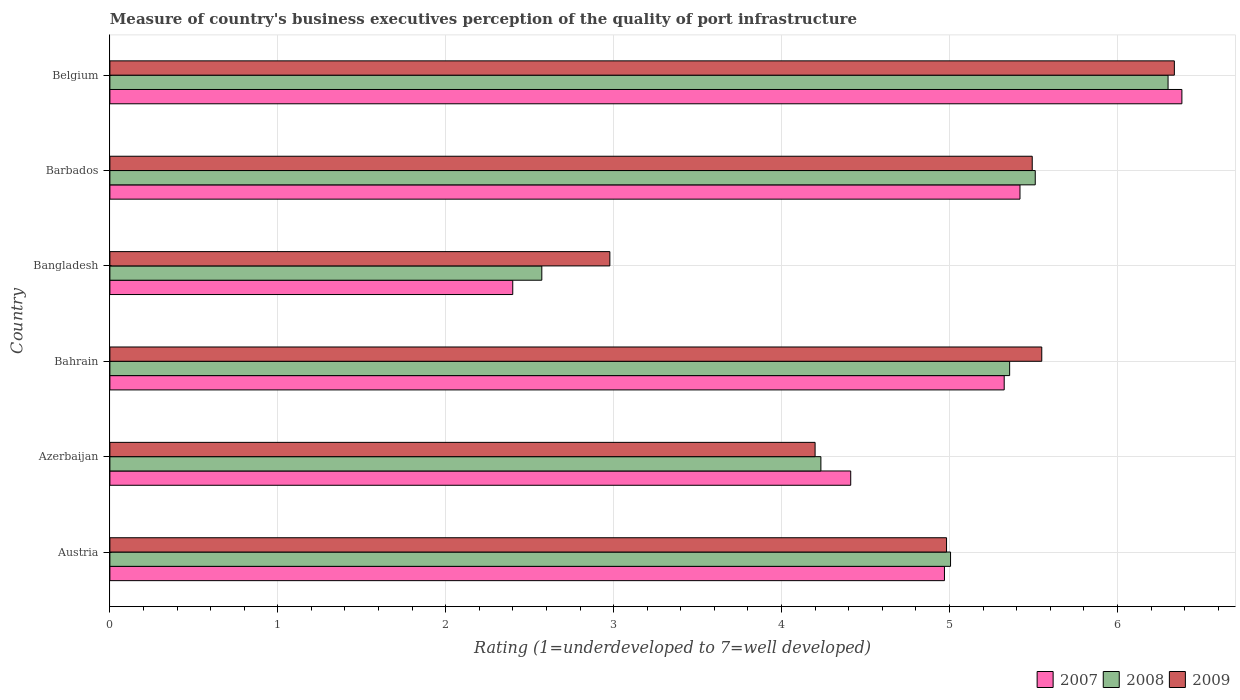How many bars are there on the 2nd tick from the bottom?
Provide a short and direct response. 3. In how many cases, is the number of bars for a given country not equal to the number of legend labels?
Your answer should be very brief. 0. What is the ratings of the quality of port infrastructure in 2007 in Bangladesh?
Your response must be concise. 2.4. Across all countries, what is the maximum ratings of the quality of port infrastructure in 2008?
Keep it short and to the point. 6.3. Across all countries, what is the minimum ratings of the quality of port infrastructure in 2009?
Provide a short and direct response. 2.98. In which country was the ratings of the quality of port infrastructure in 2007 minimum?
Give a very brief answer. Bangladesh. What is the total ratings of the quality of port infrastructure in 2007 in the graph?
Your answer should be very brief. 28.91. What is the difference between the ratings of the quality of port infrastructure in 2007 in Austria and that in Bangladesh?
Keep it short and to the point. 2.57. What is the difference between the ratings of the quality of port infrastructure in 2008 in Barbados and the ratings of the quality of port infrastructure in 2009 in Azerbaijan?
Give a very brief answer. 1.31. What is the average ratings of the quality of port infrastructure in 2008 per country?
Provide a short and direct response. 4.83. What is the difference between the ratings of the quality of port infrastructure in 2007 and ratings of the quality of port infrastructure in 2008 in Belgium?
Your answer should be very brief. 0.08. In how many countries, is the ratings of the quality of port infrastructure in 2009 greater than 4.2 ?
Offer a very short reply. 4. What is the ratio of the ratings of the quality of port infrastructure in 2007 in Bangladesh to that in Belgium?
Keep it short and to the point. 0.38. Is the ratings of the quality of port infrastructure in 2008 in Bahrain less than that in Barbados?
Give a very brief answer. Yes. Is the difference between the ratings of the quality of port infrastructure in 2007 in Bahrain and Belgium greater than the difference between the ratings of the quality of port infrastructure in 2008 in Bahrain and Belgium?
Ensure brevity in your answer.  No. What is the difference between the highest and the second highest ratings of the quality of port infrastructure in 2007?
Ensure brevity in your answer.  0.96. What is the difference between the highest and the lowest ratings of the quality of port infrastructure in 2009?
Keep it short and to the point. 3.36. Is the sum of the ratings of the quality of port infrastructure in 2009 in Bangladesh and Belgium greater than the maximum ratings of the quality of port infrastructure in 2007 across all countries?
Provide a succinct answer. Yes. What does the 1st bar from the top in Barbados represents?
Offer a terse response. 2009. How many bars are there?
Offer a very short reply. 18. How many countries are there in the graph?
Your answer should be compact. 6. What is the difference between two consecutive major ticks on the X-axis?
Your answer should be compact. 1. Are the values on the major ticks of X-axis written in scientific E-notation?
Provide a succinct answer. No. Where does the legend appear in the graph?
Your answer should be very brief. Bottom right. How many legend labels are there?
Offer a very short reply. 3. How are the legend labels stacked?
Provide a succinct answer. Horizontal. What is the title of the graph?
Make the answer very short. Measure of country's business executives perception of the quality of port infrastructure. Does "1961" appear as one of the legend labels in the graph?
Keep it short and to the point. No. What is the label or title of the X-axis?
Keep it short and to the point. Rating (1=underdeveloped to 7=well developed). What is the Rating (1=underdeveloped to 7=well developed) of 2007 in Austria?
Provide a succinct answer. 4.97. What is the Rating (1=underdeveloped to 7=well developed) in 2008 in Austria?
Provide a succinct answer. 5.01. What is the Rating (1=underdeveloped to 7=well developed) of 2009 in Austria?
Your response must be concise. 4.98. What is the Rating (1=underdeveloped to 7=well developed) of 2007 in Azerbaijan?
Your answer should be compact. 4.41. What is the Rating (1=underdeveloped to 7=well developed) of 2008 in Azerbaijan?
Provide a succinct answer. 4.23. What is the Rating (1=underdeveloped to 7=well developed) of 2009 in Azerbaijan?
Ensure brevity in your answer.  4.2. What is the Rating (1=underdeveloped to 7=well developed) of 2007 in Bahrain?
Offer a very short reply. 5.33. What is the Rating (1=underdeveloped to 7=well developed) in 2008 in Bahrain?
Your answer should be very brief. 5.36. What is the Rating (1=underdeveloped to 7=well developed) in 2009 in Bahrain?
Make the answer very short. 5.55. What is the Rating (1=underdeveloped to 7=well developed) in 2007 in Bangladesh?
Keep it short and to the point. 2.4. What is the Rating (1=underdeveloped to 7=well developed) in 2008 in Bangladesh?
Your answer should be compact. 2.57. What is the Rating (1=underdeveloped to 7=well developed) of 2009 in Bangladesh?
Your response must be concise. 2.98. What is the Rating (1=underdeveloped to 7=well developed) of 2007 in Barbados?
Make the answer very short. 5.42. What is the Rating (1=underdeveloped to 7=well developed) of 2008 in Barbados?
Your answer should be very brief. 5.51. What is the Rating (1=underdeveloped to 7=well developed) in 2009 in Barbados?
Offer a terse response. 5.49. What is the Rating (1=underdeveloped to 7=well developed) in 2007 in Belgium?
Make the answer very short. 6.38. What is the Rating (1=underdeveloped to 7=well developed) in 2008 in Belgium?
Your answer should be very brief. 6.3. What is the Rating (1=underdeveloped to 7=well developed) in 2009 in Belgium?
Make the answer very short. 6.34. Across all countries, what is the maximum Rating (1=underdeveloped to 7=well developed) of 2007?
Provide a short and direct response. 6.38. Across all countries, what is the maximum Rating (1=underdeveloped to 7=well developed) of 2008?
Offer a terse response. 6.3. Across all countries, what is the maximum Rating (1=underdeveloped to 7=well developed) in 2009?
Make the answer very short. 6.34. Across all countries, what is the minimum Rating (1=underdeveloped to 7=well developed) in 2007?
Provide a succinct answer. 2.4. Across all countries, what is the minimum Rating (1=underdeveloped to 7=well developed) of 2008?
Provide a short and direct response. 2.57. Across all countries, what is the minimum Rating (1=underdeveloped to 7=well developed) of 2009?
Give a very brief answer. 2.98. What is the total Rating (1=underdeveloped to 7=well developed) in 2007 in the graph?
Make the answer very short. 28.91. What is the total Rating (1=underdeveloped to 7=well developed) of 2008 in the graph?
Your answer should be compact. 28.98. What is the total Rating (1=underdeveloped to 7=well developed) in 2009 in the graph?
Your answer should be very brief. 29.54. What is the difference between the Rating (1=underdeveloped to 7=well developed) in 2007 in Austria and that in Azerbaijan?
Your response must be concise. 0.56. What is the difference between the Rating (1=underdeveloped to 7=well developed) of 2008 in Austria and that in Azerbaijan?
Give a very brief answer. 0.77. What is the difference between the Rating (1=underdeveloped to 7=well developed) in 2009 in Austria and that in Azerbaijan?
Your answer should be compact. 0.78. What is the difference between the Rating (1=underdeveloped to 7=well developed) in 2007 in Austria and that in Bahrain?
Make the answer very short. -0.36. What is the difference between the Rating (1=underdeveloped to 7=well developed) in 2008 in Austria and that in Bahrain?
Ensure brevity in your answer.  -0.35. What is the difference between the Rating (1=underdeveloped to 7=well developed) of 2009 in Austria and that in Bahrain?
Your answer should be compact. -0.57. What is the difference between the Rating (1=underdeveloped to 7=well developed) in 2007 in Austria and that in Bangladesh?
Keep it short and to the point. 2.57. What is the difference between the Rating (1=underdeveloped to 7=well developed) of 2008 in Austria and that in Bangladesh?
Your answer should be compact. 2.43. What is the difference between the Rating (1=underdeveloped to 7=well developed) in 2009 in Austria and that in Bangladesh?
Keep it short and to the point. 2. What is the difference between the Rating (1=underdeveloped to 7=well developed) in 2007 in Austria and that in Barbados?
Keep it short and to the point. -0.45. What is the difference between the Rating (1=underdeveloped to 7=well developed) of 2008 in Austria and that in Barbados?
Offer a very short reply. -0.5. What is the difference between the Rating (1=underdeveloped to 7=well developed) of 2009 in Austria and that in Barbados?
Give a very brief answer. -0.51. What is the difference between the Rating (1=underdeveloped to 7=well developed) of 2007 in Austria and that in Belgium?
Keep it short and to the point. -1.41. What is the difference between the Rating (1=underdeveloped to 7=well developed) in 2008 in Austria and that in Belgium?
Give a very brief answer. -1.3. What is the difference between the Rating (1=underdeveloped to 7=well developed) in 2009 in Austria and that in Belgium?
Give a very brief answer. -1.36. What is the difference between the Rating (1=underdeveloped to 7=well developed) in 2007 in Azerbaijan and that in Bahrain?
Make the answer very short. -0.91. What is the difference between the Rating (1=underdeveloped to 7=well developed) in 2008 in Azerbaijan and that in Bahrain?
Provide a short and direct response. -1.12. What is the difference between the Rating (1=underdeveloped to 7=well developed) of 2009 in Azerbaijan and that in Bahrain?
Provide a short and direct response. -1.35. What is the difference between the Rating (1=underdeveloped to 7=well developed) in 2007 in Azerbaijan and that in Bangladesh?
Ensure brevity in your answer.  2.01. What is the difference between the Rating (1=underdeveloped to 7=well developed) of 2008 in Azerbaijan and that in Bangladesh?
Your response must be concise. 1.66. What is the difference between the Rating (1=underdeveloped to 7=well developed) of 2009 in Azerbaijan and that in Bangladesh?
Offer a terse response. 1.22. What is the difference between the Rating (1=underdeveloped to 7=well developed) in 2007 in Azerbaijan and that in Barbados?
Provide a succinct answer. -1.01. What is the difference between the Rating (1=underdeveloped to 7=well developed) in 2008 in Azerbaijan and that in Barbados?
Make the answer very short. -1.28. What is the difference between the Rating (1=underdeveloped to 7=well developed) of 2009 in Azerbaijan and that in Barbados?
Make the answer very short. -1.29. What is the difference between the Rating (1=underdeveloped to 7=well developed) of 2007 in Azerbaijan and that in Belgium?
Your answer should be compact. -1.97. What is the difference between the Rating (1=underdeveloped to 7=well developed) of 2008 in Azerbaijan and that in Belgium?
Offer a very short reply. -2.07. What is the difference between the Rating (1=underdeveloped to 7=well developed) of 2009 in Azerbaijan and that in Belgium?
Your answer should be very brief. -2.14. What is the difference between the Rating (1=underdeveloped to 7=well developed) in 2007 in Bahrain and that in Bangladesh?
Offer a terse response. 2.93. What is the difference between the Rating (1=underdeveloped to 7=well developed) in 2008 in Bahrain and that in Bangladesh?
Your answer should be compact. 2.79. What is the difference between the Rating (1=underdeveloped to 7=well developed) in 2009 in Bahrain and that in Bangladesh?
Provide a succinct answer. 2.57. What is the difference between the Rating (1=underdeveloped to 7=well developed) of 2007 in Bahrain and that in Barbados?
Provide a short and direct response. -0.09. What is the difference between the Rating (1=underdeveloped to 7=well developed) in 2008 in Bahrain and that in Barbados?
Make the answer very short. -0.15. What is the difference between the Rating (1=underdeveloped to 7=well developed) in 2009 in Bahrain and that in Barbados?
Keep it short and to the point. 0.06. What is the difference between the Rating (1=underdeveloped to 7=well developed) in 2007 in Bahrain and that in Belgium?
Ensure brevity in your answer.  -1.06. What is the difference between the Rating (1=underdeveloped to 7=well developed) of 2008 in Bahrain and that in Belgium?
Give a very brief answer. -0.94. What is the difference between the Rating (1=underdeveloped to 7=well developed) of 2009 in Bahrain and that in Belgium?
Keep it short and to the point. -0.79. What is the difference between the Rating (1=underdeveloped to 7=well developed) in 2007 in Bangladesh and that in Barbados?
Provide a short and direct response. -3.02. What is the difference between the Rating (1=underdeveloped to 7=well developed) of 2008 in Bangladesh and that in Barbados?
Offer a very short reply. -2.94. What is the difference between the Rating (1=underdeveloped to 7=well developed) of 2009 in Bangladesh and that in Barbados?
Keep it short and to the point. -2.52. What is the difference between the Rating (1=underdeveloped to 7=well developed) in 2007 in Bangladesh and that in Belgium?
Give a very brief answer. -3.98. What is the difference between the Rating (1=underdeveloped to 7=well developed) of 2008 in Bangladesh and that in Belgium?
Your answer should be compact. -3.73. What is the difference between the Rating (1=underdeveloped to 7=well developed) of 2009 in Bangladesh and that in Belgium?
Ensure brevity in your answer.  -3.36. What is the difference between the Rating (1=underdeveloped to 7=well developed) in 2007 in Barbados and that in Belgium?
Provide a short and direct response. -0.96. What is the difference between the Rating (1=underdeveloped to 7=well developed) of 2008 in Barbados and that in Belgium?
Make the answer very short. -0.79. What is the difference between the Rating (1=underdeveloped to 7=well developed) in 2009 in Barbados and that in Belgium?
Your answer should be very brief. -0.85. What is the difference between the Rating (1=underdeveloped to 7=well developed) of 2007 in Austria and the Rating (1=underdeveloped to 7=well developed) of 2008 in Azerbaijan?
Ensure brevity in your answer.  0.74. What is the difference between the Rating (1=underdeveloped to 7=well developed) in 2007 in Austria and the Rating (1=underdeveloped to 7=well developed) in 2009 in Azerbaijan?
Your answer should be very brief. 0.77. What is the difference between the Rating (1=underdeveloped to 7=well developed) in 2008 in Austria and the Rating (1=underdeveloped to 7=well developed) in 2009 in Azerbaijan?
Give a very brief answer. 0.81. What is the difference between the Rating (1=underdeveloped to 7=well developed) of 2007 in Austria and the Rating (1=underdeveloped to 7=well developed) of 2008 in Bahrain?
Provide a succinct answer. -0.39. What is the difference between the Rating (1=underdeveloped to 7=well developed) in 2007 in Austria and the Rating (1=underdeveloped to 7=well developed) in 2009 in Bahrain?
Offer a very short reply. -0.58. What is the difference between the Rating (1=underdeveloped to 7=well developed) in 2008 in Austria and the Rating (1=underdeveloped to 7=well developed) in 2009 in Bahrain?
Your answer should be very brief. -0.54. What is the difference between the Rating (1=underdeveloped to 7=well developed) in 2007 in Austria and the Rating (1=underdeveloped to 7=well developed) in 2008 in Bangladesh?
Provide a short and direct response. 2.4. What is the difference between the Rating (1=underdeveloped to 7=well developed) in 2007 in Austria and the Rating (1=underdeveloped to 7=well developed) in 2009 in Bangladesh?
Ensure brevity in your answer.  1.99. What is the difference between the Rating (1=underdeveloped to 7=well developed) in 2008 in Austria and the Rating (1=underdeveloped to 7=well developed) in 2009 in Bangladesh?
Provide a succinct answer. 2.03. What is the difference between the Rating (1=underdeveloped to 7=well developed) of 2007 in Austria and the Rating (1=underdeveloped to 7=well developed) of 2008 in Barbados?
Your response must be concise. -0.54. What is the difference between the Rating (1=underdeveloped to 7=well developed) in 2007 in Austria and the Rating (1=underdeveloped to 7=well developed) in 2009 in Barbados?
Your response must be concise. -0.52. What is the difference between the Rating (1=underdeveloped to 7=well developed) of 2008 in Austria and the Rating (1=underdeveloped to 7=well developed) of 2009 in Barbados?
Offer a very short reply. -0.49. What is the difference between the Rating (1=underdeveloped to 7=well developed) of 2007 in Austria and the Rating (1=underdeveloped to 7=well developed) of 2008 in Belgium?
Provide a succinct answer. -1.33. What is the difference between the Rating (1=underdeveloped to 7=well developed) in 2007 in Austria and the Rating (1=underdeveloped to 7=well developed) in 2009 in Belgium?
Your response must be concise. -1.37. What is the difference between the Rating (1=underdeveloped to 7=well developed) in 2008 in Austria and the Rating (1=underdeveloped to 7=well developed) in 2009 in Belgium?
Give a very brief answer. -1.33. What is the difference between the Rating (1=underdeveloped to 7=well developed) of 2007 in Azerbaijan and the Rating (1=underdeveloped to 7=well developed) of 2008 in Bahrain?
Provide a short and direct response. -0.95. What is the difference between the Rating (1=underdeveloped to 7=well developed) in 2007 in Azerbaijan and the Rating (1=underdeveloped to 7=well developed) in 2009 in Bahrain?
Ensure brevity in your answer.  -1.14. What is the difference between the Rating (1=underdeveloped to 7=well developed) in 2008 in Azerbaijan and the Rating (1=underdeveloped to 7=well developed) in 2009 in Bahrain?
Offer a terse response. -1.32. What is the difference between the Rating (1=underdeveloped to 7=well developed) in 2007 in Azerbaijan and the Rating (1=underdeveloped to 7=well developed) in 2008 in Bangladesh?
Keep it short and to the point. 1.84. What is the difference between the Rating (1=underdeveloped to 7=well developed) of 2007 in Azerbaijan and the Rating (1=underdeveloped to 7=well developed) of 2009 in Bangladesh?
Ensure brevity in your answer.  1.43. What is the difference between the Rating (1=underdeveloped to 7=well developed) of 2008 in Azerbaijan and the Rating (1=underdeveloped to 7=well developed) of 2009 in Bangladesh?
Provide a short and direct response. 1.26. What is the difference between the Rating (1=underdeveloped to 7=well developed) of 2007 in Azerbaijan and the Rating (1=underdeveloped to 7=well developed) of 2008 in Barbados?
Your answer should be compact. -1.1. What is the difference between the Rating (1=underdeveloped to 7=well developed) of 2007 in Azerbaijan and the Rating (1=underdeveloped to 7=well developed) of 2009 in Barbados?
Ensure brevity in your answer.  -1.08. What is the difference between the Rating (1=underdeveloped to 7=well developed) of 2008 in Azerbaijan and the Rating (1=underdeveloped to 7=well developed) of 2009 in Barbados?
Keep it short and to the point. -1.26. What is the difference between the Rating (1=underdeveloped to 7=well developed) of 2007 in Azerbaijan and the Rating (1=underdeveloped to 7=well developed) of 2008 in Belgium?
Ensure brevity in your answer.  -1.89. What is the difference between the Rating (1=underdeveloped to 7=well developed) in 2007 in Azerbaijan and the Rating (1=underdeveloped to 7=well developed) in 2009 in Belgium?
Offer a terse response. -1.93. What is the difference between the Rating (1=underdeveloped to 7=well developed) in 2008 in Azerbaijan and the Rating (1=underdeveloped to 7=well developed) in 2009 in Belgium?
Give a very brief answer. -2.1. What is the difference between the Rating (1=underdeveloped to 7=well developed) in 2007 in Bahrain and the Rating (1=underdeveloped to 7=well developed) in 2008 in Bangladesh?
Give a very brief answer. 2.75. What is the difference between the Rating (1=underdeveloped to 7=well developed) of 2007 in Bahrain and the Rating (1=underdeveloped to 7=well developed) of 2009 in Bangladesh?
Make the answer very short. 2.35. What is the difference between the Rating (1=underdeveloped to 7=well developed) of 2008 in Bahrain and the Rating (1=underdeveloped to 7=well developed) of 2009 in Bangladesh?
Ensure brevity in your answer.  2.38. What is the difference between the Rating (1=underdeveloped to 7=well developed) of 2007 in Bahrain and the Rating (1=underdeveloped to 7=well developed) of 2008 in Barbados?
Keep it short and to the point. -0.18. What is the difference between the Rating (1=underdeveloped to 7=well developed) in 2007 in Bahrain and the Rating (1=underdeveloped to 7=well developed) in 2009 in Barbados?
Offer a very short reply. -0.17. What is the difference between the Rating (1=underdeveloped to 7=well developed) of 2008 in Bahrain and the Rating (1=underdeveloped to 7=well developed) of 2009 in Barbados?
Provide a short and direct response. -0.13. What is the difference between the Rating (1=underdeveloped to 7=well developed) in 2007 in Bahrain and the Rating (1=underdeveloped to 7=well developed) in 2008 in Belgium?
Offer a very short reply. -0.98. What is the difference between the Rating (1=underdeveloped to 7=well developed) of 2007 in Bahrain and the Rating (1=underdeveloped to 7=well developed) of 2009 in Belgium?
Provide a succinct answer. -1.01. What is the difference between the Rating (1=underdeveloped to 7=well developed) in 2008 in Bahrain and the Rating (1=underdeveloped to 7=well developed) in 2009 in Belgium?
Provide a succinct answer. -0.98. What is the difference between the Rating (1=underdeveloped to 7=well developed) in 2007 in Bangladesh and the Rating (1=underdeveloped to 7=well developed) in 2008 in Barbados?
Offer a terse response. -3.11. What is the difference between the Rating (1=underdeveloped to 7=well developed) in 2007 in Bangladesh and the Rating (1=underdeveloped to 7=well developed) in 2009 in Barbados?
Provide a short and direct response. -3.09. What is the difference between the Rating (1=underdeveloped to 7=well developed) in 2008 in Bangladesh and the Rating (1=underdeveloped to 7=well developed) in 2009 in Barbados?
Offer a very short reply. -2.92. What is the difference between the Rating (1=underdeveloped to 7=well developed) in 2007 in Bangladesh and the Rating (1=underdeveloped to 7=well developed) in 2008 in Belgium?
Keep it short and to the point. -3.9. What is the difference between the Rating (1=underdeveloped to 7=well developed) of 2007 in Bangladesh and the Rating (1=underdeveloped to 7=well developed) of 2009 in Belgium?
Ensure brevity in your answer.  -3.94. What is the difference between the Rating (1=underdeveloped to 7=well developed) of 2008 in Bangladesh and the Rating (1=underdeveloped to 7=well developed) of 2009 in Belgium?
Give a very brief answer. -3.77. What is the difference between the Rating (1=underdeveloped to 7=well developed) in 2007 in Barbados and the Rating (1=underdeveloped to 7=well developed) in 2008 in Belgium?
Ensure brevity in your answer.  -0.88. What is the difference between the Rating (1=underdeveloped to 7=well developed) of 2007 in Barbados and the Rating (1=underdeveloped to 7=well developed) of 2009 in Belgium?
Make the answer very short. -0.92. What is the difference between the Rating (1=underdeveloped to 7=well developed) in 2008 in Barbados and the Rating (1=underdeveloped to 7=well developed) in 2009 in Belgium?
Your answer should be compact. -0.83. What is the average Rating (1=underdeveloped to 7=well developed) of 2007 per country?
Your response must be concise. 4.82. What is the average Rating (1=underdeveloped to 7=well developed) of 2008 per country?
Provide a short and direct response. 4.83. What is the average Rating (1=underdeveloped to 7=well developed) of 2009 per country?
Your response must be concise. 4.92. What is the difference between the Rating (1=underdeveloped to 7=well developed) of 2007 and Rating (1=underdeveloped to 7=well developed) of 2008 in Austria?
Ensure brevity in your answer.  -0.04. What is the difference between the Rating (1=underdeveloped to 7=well developed) in 2007 and Rating (1=underdeveloped to 7=well developed) in 2009 in Austria?
Offer a very short reply. -0.01. What is the difference between the Rating (1=underdeveloped to 7=well developed) of 2008 and Rating (1=underdeveloped to 7=well developed) of 2009 in Austria?
Provide a short and direct response. 0.02. What is the difference between the Rating (1=underdeveloped to 7=well developed) in 2007 and Rating (1=underdeveloped to 7=well developed) in 2008 in Azerbaijan?
Offer a very short reply. 0.18. What is the difference between the Rating (1=underdeveloped to 7=well developed) of 2007 and Rating (1=underdeveloped to 7=well developed) of 2009 in Azerbaijan?
Ensure brevity in your answer.  0.21. What is the difference between the Rating (1=underdeveloped to 7=well developed) in 2008 and Rating (1=underdeveloped to 7=well developed) in 2009 in Azerbaijan?
Ensure brevity in your answer.  0.03. What is the difference between the Rating (1=underdeveloped to 7=well developed) of 2007 and Rating (1=underdeveloped to 7=well developed) of 2008 in Bahrain?
Your response must be concise. -0.03. What is the difference between the Rating (1=underdeveloped to 7=well developed) of 2007 and Rating (1=underdeveloped to 7=well developed) of 2009 in Bahrain?
Give a very brief answer. -0.22. What is the difference between the Rating (1=underdeveloped to 7=well developed) in 2008 and Rating (1=underdeveloped to 7=well developed) in 2009 in Bahrain?
Offer a very short reply. -0.19. What is the difference between the Rating (1=underdeveloped to 7=well developed) in 2007 and Rating (1=underdeveloped to 7=well developed) in 2008 in Bangladesh?
Your answer should be very brief. -0.17. What is the difference between the Rating (1=underdeveloped to 7=well developed) of 2007 and Rating (1=underdeveloped to 7=well developed) of 2009 in Bangladesh?
Offer a terse response. -0.58. What is the difference between the Rating (1=underdeveloped to 7=well developed) of 2008 and Rating (1=underdeveloped to 7=well developed) of 2009 in Bangladesh?
Provide a succinct answer. -0.41. What is the difference between the Rating (1=underdeveloped to 7=well developed) of 2007 and Rating (1=underdeveloped to 7=well developed) of 2008 in Barbados?
Provide a short and direct response. -0.09. What is the difference between the Rating (1=underdeveloped to 7=well developed) in 2007 and Rating (1=underdeveloped to 7=well developed) in 2009 in Barbados?
Make the answer very short. -0.07. What is the difference between the Rating (1=underdeveloped to 7=well developed) in 2008 and Rating (1=underdeveloped to 7=well developed) in 2009 in Barbados?
Make the answer very short. 0.02. What is the difference between the Rating (1=underdeveloped to 7=well developed) of 2007 and Rating (1=underdeveloped to 7=well developed) of 2008 in Belgium?
Provide a short and direct response. 0.08. What is the difference between the Rating (1=underdeveloped to 7=well developed) of 2007 and Rating (1=underdeveloped to 7=well developed) of 2009 in Belgium?
Your answer should be compact. 0.04. What is the difference between the Rating (1=underdeveloped to 7=well developed) in 2008 and Rating (1=underdeveloped to 7=well developed) in 2009 in Belgium?
Provide a short and direct response. -0.04. What is the ratio of the Rating (1=underdeveloped to 7=well developed) of 2007 in Austria to that in Azerbaijan?
Your answer should be very brief. 1.13. What is the ratio of the Rating (1=underdeveloped to 7=well developed) in 2008 in Austria to that in Azerbaijan?
Provide a short and direct response. 1.18. What is the ratio of the Rating (1=underdeveloped to 7=well developed) in 2009 in Austria to that in Azerbaijan?
Offer a very short reply. 1.19. What is the ratio of the Rating (1=underdeveloped to 7=well developed) of 2007 in Austria to that in Bahrain?
Keep it short and to the point. 0.93. What is the ratio of the Rating (1=underdeveloped to 7=well developed) of 2008 in Austria to that in Bahrain?
Provide a succinct answer. 0.93. What is the ratio of the Rating (1=underdeveloped to 7=well developed) in 2009 in Austria to that in Bahrain?
Make the answer very short. 0.9. What is the ratio of the Rating (1=underdeveloped to 7=well developed) in 2007 in Austria to that in Bangladesh?
Give a very brief answer. 2.07. What is the ratio of the Rating (1=underdeveloped to 7=well developed) of 2008 in Austria to that in Bangladesh?
Keep it short and to the point. 1.95. What is the ratio of the Rating (1=underdeveloped to 7=well developed) of 2009 in Austria to that in Bangladesh?
Make the answer very short. 1.67. What is the ratio of the Rating (1=underdeveloped to 7=well developed) of 2007 in Austria to that in Barbados?
Ensure brevity in your answer.  0.92. What is the ratio of the Rating (1=underdeveloped to 7=well developed) of 2008 in Austria to that in Barbados?
Provide a succinct answer. 0.91. What is the ratio of the Rating (1=underdeveloped to 7=well developed) in 2009 in Austria to that in Barbados?
Your response must be concise. 0.91. What is the ratio of the Rating (1=underdeveloped to 7=well developed) in 2007 in Austria to that in Belgium?
Make the answer very short. 0.78. What is the ratio of the Rating (1=underdeveloped to 7=well developed) in 2008 in Austria to that in Belgium?
Your response must be concise. 0.79. What is the ratio of the Rating (1=underdeveloped to 7=well developed) in 2009 in Austria to that in Belgium?
Provide a short and direct response. 0.79. What is the ratio of the Rating (1=underdeveloped to 7=well developed) in 2007 in Azerbaijan to that in Bahrain?
Ensure brevity in your answer.  0.83. What is the ratio of the Rating (1=underdeveloped to 7=well developed) in 2008 in Azerbaijan to that in Bahrain?
Your answer should be very brief. 0.79. What is the ratio of the Rating (1=underdeveloped to 7=well developed) in 2009 in Azerbaijan to that in Bahrain?
Your response must be concise. 0.76. What is the ratio of the Rating (1=underdeveloped to 7=well developed) in 2007 in Azerbaijan to that in Bangladesh?
Make the answer very short. 1.84. What is the ratio of the Rating (1=underdeveloped to 7=well developed) of 2008 in Azerbaijan to that in Bangladesh?
Ensure brevity in your answer.  1.65. What is the ratio of the Rating (1=underdeveloped to 7=well developed) in 2009 in Azerbaijan to that in Bangladesh?
Ensure brevity in your answer.  1.41. What is the ratio of the Rating (1=underdeveloped to 7=well developed) of 2007 in Azerbaijan to that in Barbados?
Keep it short and to the point. 0.81. What is the ratio of the Rating (1=underdeveloped to 7=well developed) in 2008 in Azerbaijan to that in Barbados?
Your response must be concise. 0.77. What is the ratio of the Rating (1=underdeveloped to 7=well developed) in 2009 in Azerbaijan to that in Barbados?
Your answer should be very brief. 0.76. What is the ratio of the Rating (1=underdeveloped to 7=well developed) in 2007 in Azerbaijan to that in Belgium?
Provide a succinct answer. 0.69. What is the ratio of the Rating (1=underdeveloped to 7=well developed) of 2008 in Azerbaijan to that in Belgium?
Your response must be concise. 0.67. What is the ratio of the Rating (1=underdeveloped to 7=well developed) of 2009 in Azerbaijan to that in Belgium?
Keep it short and to the point. 0.66. What is the ratio of the Rating (1=underdeveloped to 7=well developed) in 2007 in Bahrain to that in Bangladesh?
Give a very brief answer. 2.22. What is the ratio of the Rating (1=underdeveloped to 7=well developed) in 2008 in Bahrain to that in Bangladesh?
Ensure brevity in your answer.  2.08. What is the ratio of the Rating (1=underdeveloped to 7=well developed) of 2009 in Bahrain to that in Bangladesh?
Your answer should be compact. 1.86. What is the ratio of the Rating (1=underdeveloped to 7=well developed) in 2007 in Bahrain to that in Barbados?
Your answer should be very brief. 0.98. What is the ratio of the Rating (1=underdeveloped to 7=well developed) in 2008 in Bahrain to that in Barbados?
Provide a succinct answer. 0.97. What is the ratio of the Rating (1=underdeveloped to 7=well developed) in 2009 in Bahrain to that in Barbados?
Your response must be concise. 1.01. What is the ratio of the Rating (1=underdeveloped to 7=well developed) of 2007 in Bahrain to that in Belgium?
Provide a short and direct response. 0.83. What is the ratio of the Rating (1=underdeveloped to 7=well developed) in 2008 in Bahrain to that in Belgium?
Your response must be concise. 0.85. What is the ratio of the Rating (1=underdeveloped to 7=well developed) in 2009 in Bahrain to that in Belgium?
Make the answer very short. 0.88. What is the ratio of the Rating (1=underdeveloped to 7=well developed) in 2007 in Bangladesh to that in Barbados?
Your response must be concise. 0.44. What is the ratio of the Rating (1=underdeveloped to 7=well developed) in 2008 in Bangladesh to that in Barbados?
Offer a very short reply. 0.47. What is the ratio of the Rating (1=underdeveloped to 7=well developed) in 2009 in Bangladesh to that in Barbados?
Keep it short and to the point. 0.54. What is the ratio of the Rating (1=underdeveloped to 7=well developed) of 2007 in Bangladesh to that in Belgium?
Make the answer very short. 0.38. What is the ratio of the Rating (1=underdeveloped to 7=well developed) in 2008 in Bangladesh to that in Belgium?
Give a very brief answer. 0.41. What is the ratio of the Rating (1=underdeveloped to 7=well developed) of 2009 in Bangladesh to that in Belgium?
Give a very brief answer. 0.47. What is the ratio of the Rating (1=underdeveloped to 7=well developed) of 2007 in Barbados to that in Belgium?
Your response must be concise. 0.85. What is the ratio of the Rating (1=underdeveloped to 7=well developed) of 2008 in Barbados to that in Belgium?
Offer a very short reply. 0.87. What is the ratio of the Rating (1=underdeveloped to 7=well developed) in 2009 in Barbados to that in Belgium?
Ensure brevity in your answer.  0.87. What is the difference between the highest and the second highest Rating (1=underdeveloped to 7=well developed) in 2007?
Your response must be concise. 0.96. What is the difference between the highest and the second highest Rating (1=underdeveloped to 7=well developed) in 2008?
Offer a very short reply. 0.79. What is the difference between the highest and the second highest Rating (1=underdeveloped to 7=well developed) in 2009?
Provide a succinct answer. 0.79. What is the difference between the highest and the lowest Rating (1=underdeveloped to 7=well developed) in 2007?
Your response must be concise. 3.98. What is the difference between the highest and the lowest Rating (1=underdeveloped to 7=well developed) in 2008?
Provide a short and direct response. 3.73. What is the difference between the highest and the lowest Rating (1=underdeveloped to 7=well developed) in 2009?
Keep it short and to the point. 3.36. 